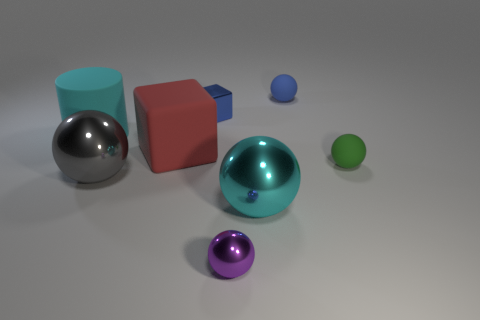How many other objects are the same color as the shiny block?
Provide a short and direct response. 1. Is the number of small things left of the small blue cube less than the number of green balls that are on the right side of the small green matte object?
Offer a very short reply. No. Do the red rubber block and the rubber ball behind the green matte sphere have the same size?
Your answer should be compact. No. What number of rubber things are the same size as the blue cube?
Keep it short and to the point. 2. The tiny object that is the same material as the small block is what color?
Provide a succinct answer. Purple. Are there more tiny cyan matte objects than tiny shiny objects?
Your answer should be compact. No. Does the cylinder have the same material as the cyan ball?
Give a very brief answer. No. The green thing that is made of the same material as the red thing is what shape?
Your answer should be compact. Sphere. Is the number of tiny red objects less than the number of big cyan cylinders?
Your answer should be compact. Yes. What material is the thing that is both to the left of the large matte block and in front of the green sphere?
Keep it short and to the point. Metal. 